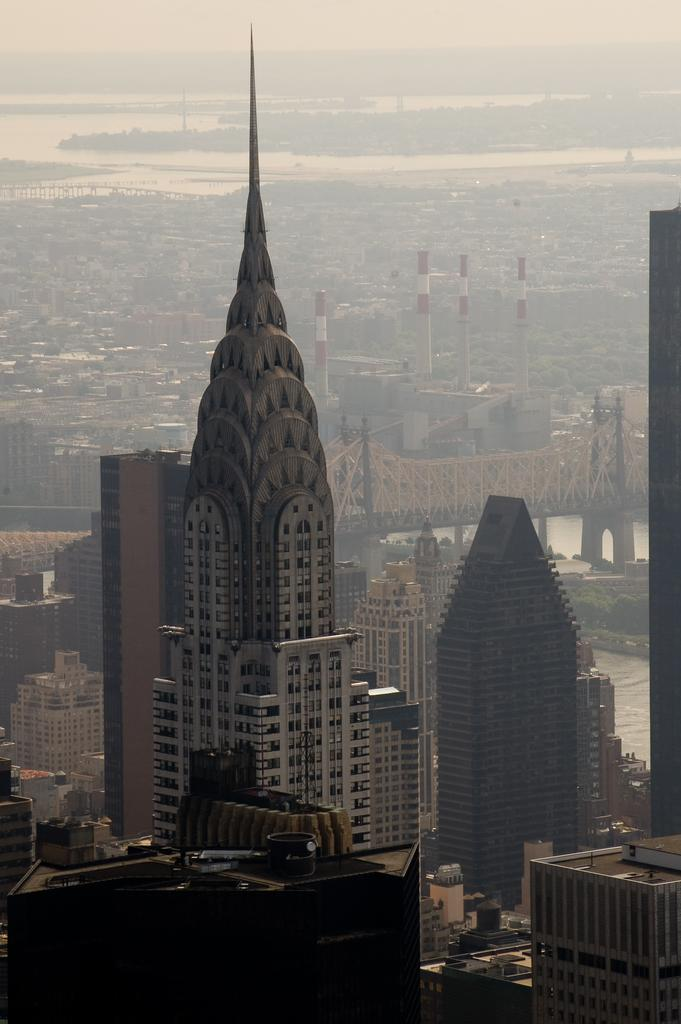What type of structures can be seen in the image? There are buildings, a bridge, and towers in the image. What natural feature is present in the image? There is a river in the image. What is visible in the background of the image? The sky is visible in the image. Can you see any wine being served on the bridge in the image? There is no wine or any indication of serving wine in the image. Is there a cat visible on top of one of the towers in the image? There is no cat present in the image. 